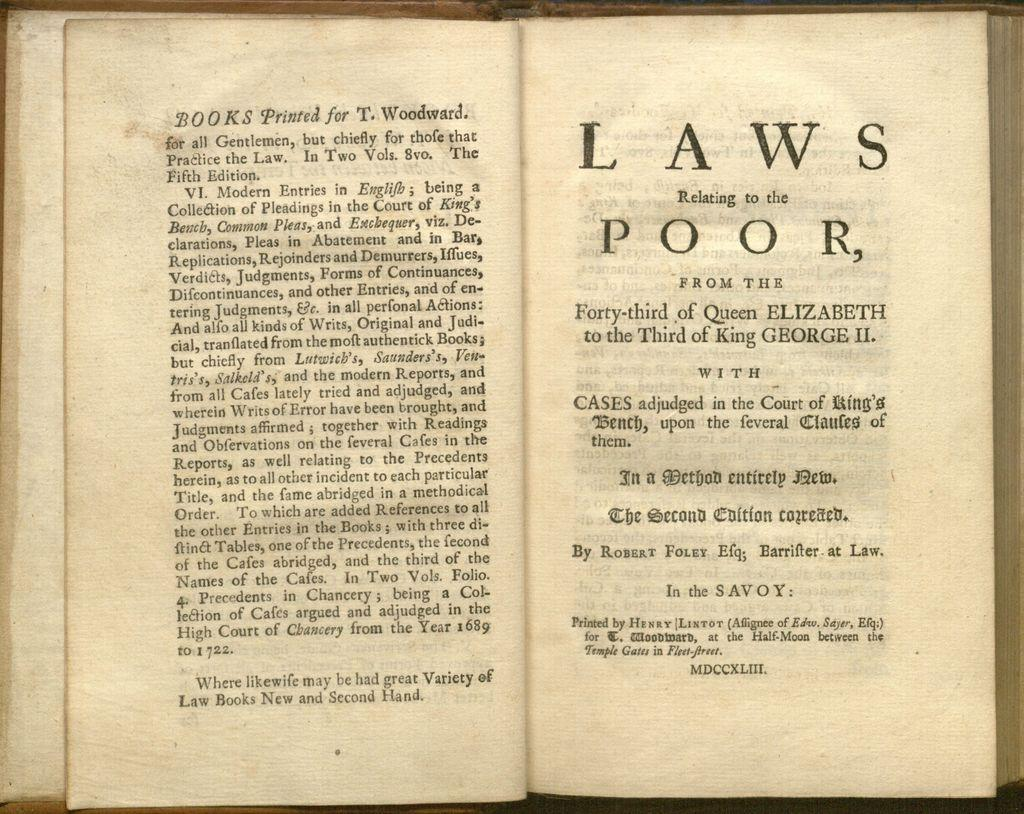<image>
Give a short and clear explanation of the subsequent image. An old book with the title of Laws Relating to the Poor. 